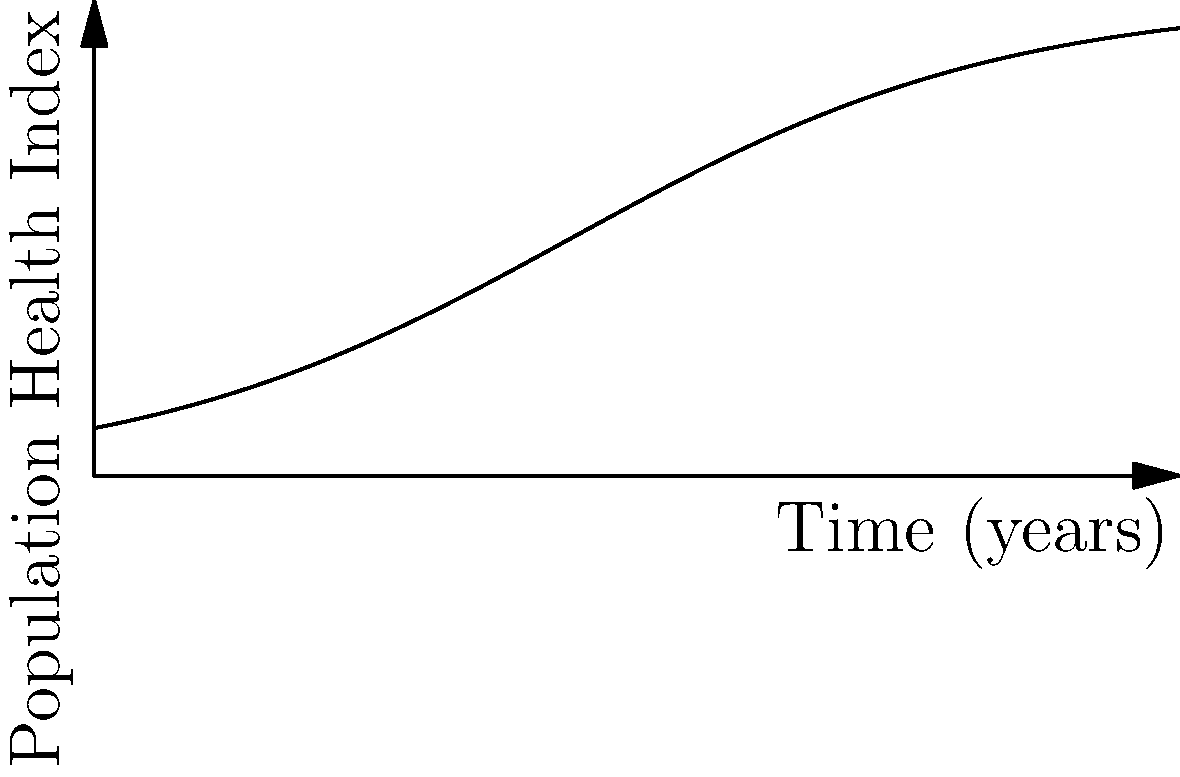The population health index $H(t)$ of a region over time $t$ (in years) is modeled by the function:

$$H(t) = \frac{100}{1 + 9e^{-0.5t}}$$

Calculate the rate of change of the population health index after 5 years. Round your answer to two decimal places. To find the rate of change of the population health index after 5 years, we need to follow these steps:

1) First, we need to find the derivative of $H(t)$ with respect to $t$. Let's call this $H'(t)$.

2) Using the quotient rule, we get:

   $$H'(t) = \frac{(1 + 9e^{-0.5t}) \cdot 0 - 100 \cdot (-4.5e^{-0.5t})}{(1 + 9e^{-0.5t})^2}$$

3) Simplifying:

   $$H'(t) = \frac{450e^{-0.5t}}{(1 + 9e^{-0.5t})^2}$$

4) Now, we need to evaluate this at $t = 5$:

   $$H'(5) = \frac{450e^{-0.5(5)}}{(1 + 9e^{-0.5(5)})^2}$$

5) Let's calculate this step by step:
   
   $e^{-2.5} \approx 0.0821$
   
   $450 \cdot 0.0821 \approx 36.945$
   
   $1 + 9 \cdot 0.0821 \approx 1.7389$
   
   $(1.7389)^2 \approx 3.0238$

6) Therefore:

   $$H'(5) \approx \frac{36.945}{3.0238} \approx 12.22$$

7) Rounding to two decimal places, we get 12.22.
Answer: 12.22 